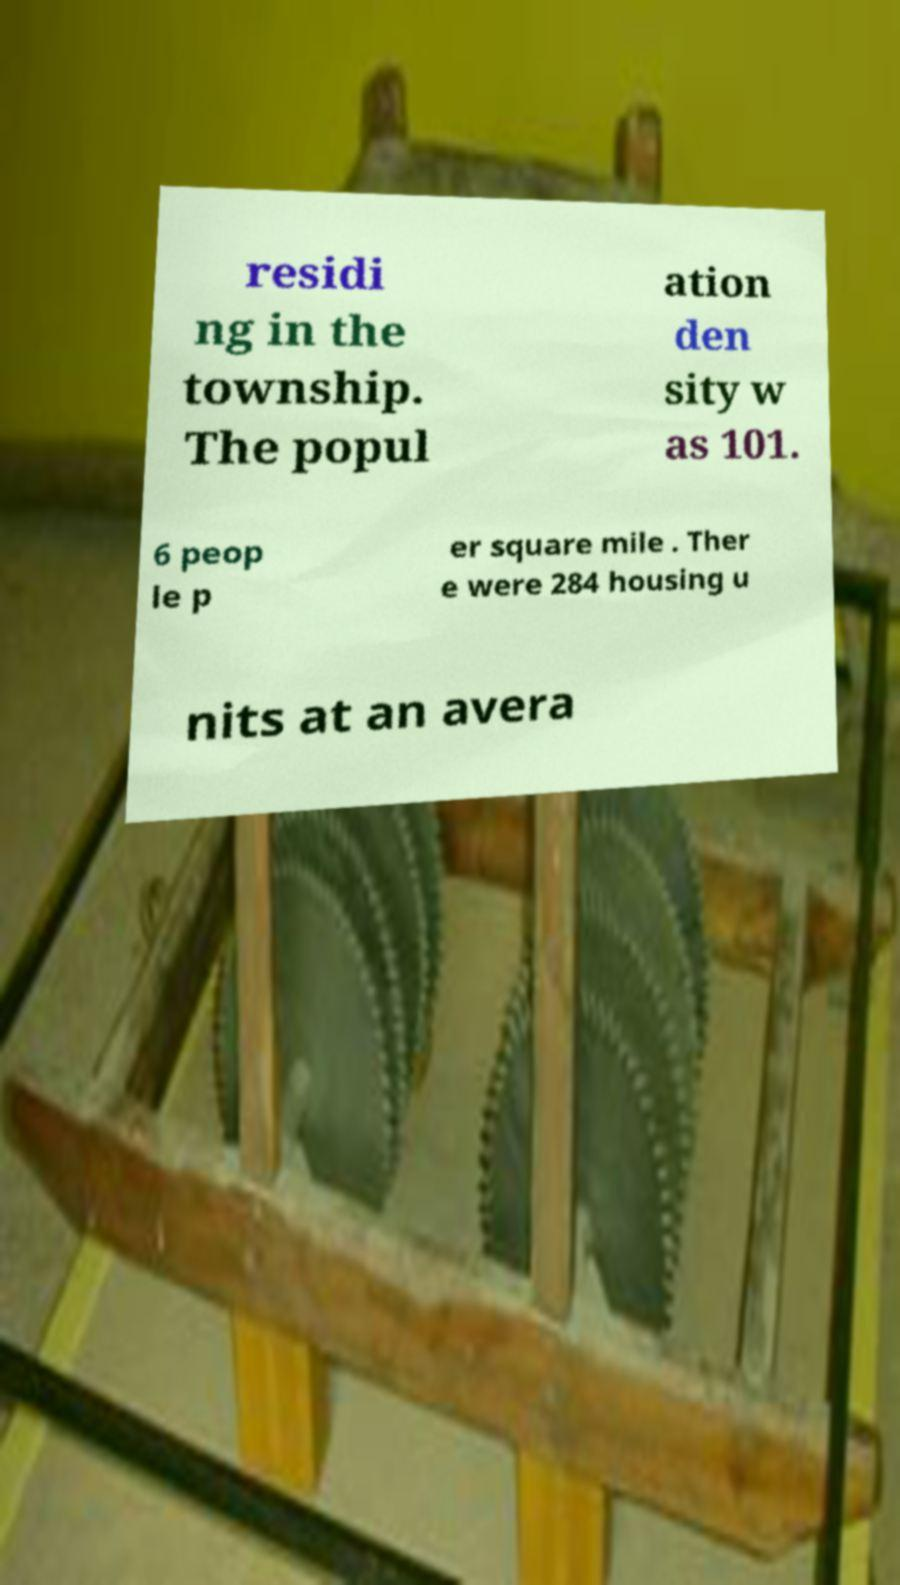Could you assist in decoding the text presented in this image and type it out clearly? residi ng in the township. The popul ation den sity w as 101. 6 peop le p er square mile . Ther e were 284 housing u nits at an avera 